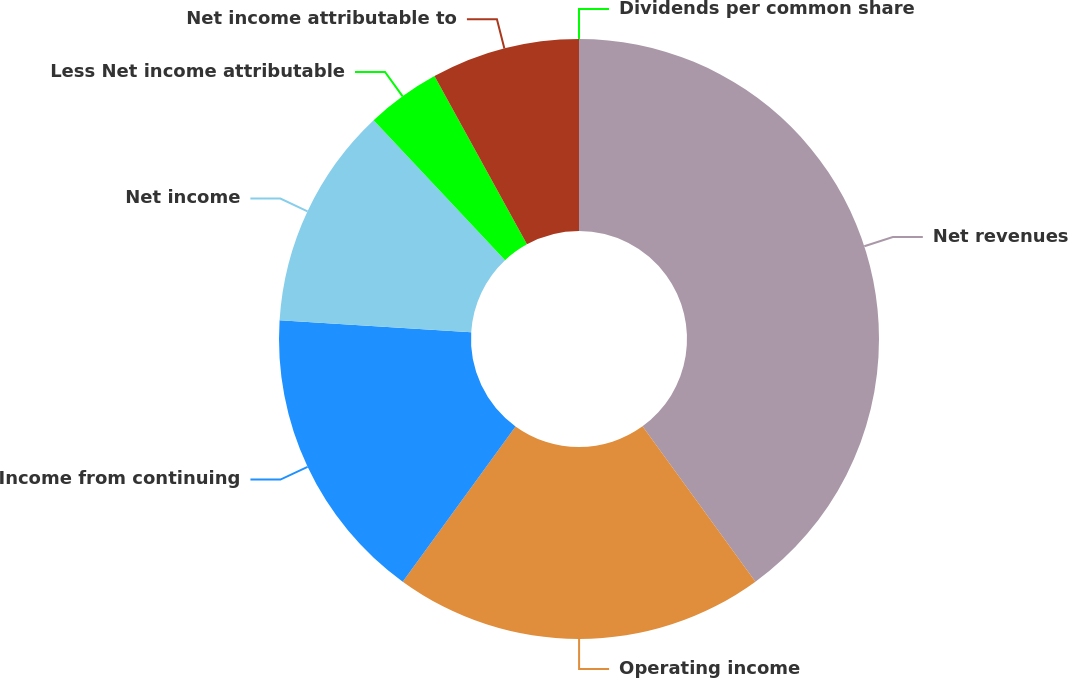<chart> <loc_0><loc_0><loc_500><loc_500><pie_chart><fcel>Net revenues<fcel>Operating income<fcel>Income from continuing<fcel>Net income<fcel>Less Net income attributable<fcel>Net income attributable to<fcel>Dividends per common share<nl><fcel>39.99%<fcel>20.0%<fcel>16.0%<fcel>12.0%<fcel>4.0%<fcel>8.0%<fcel>0.0%<nl></chart> 